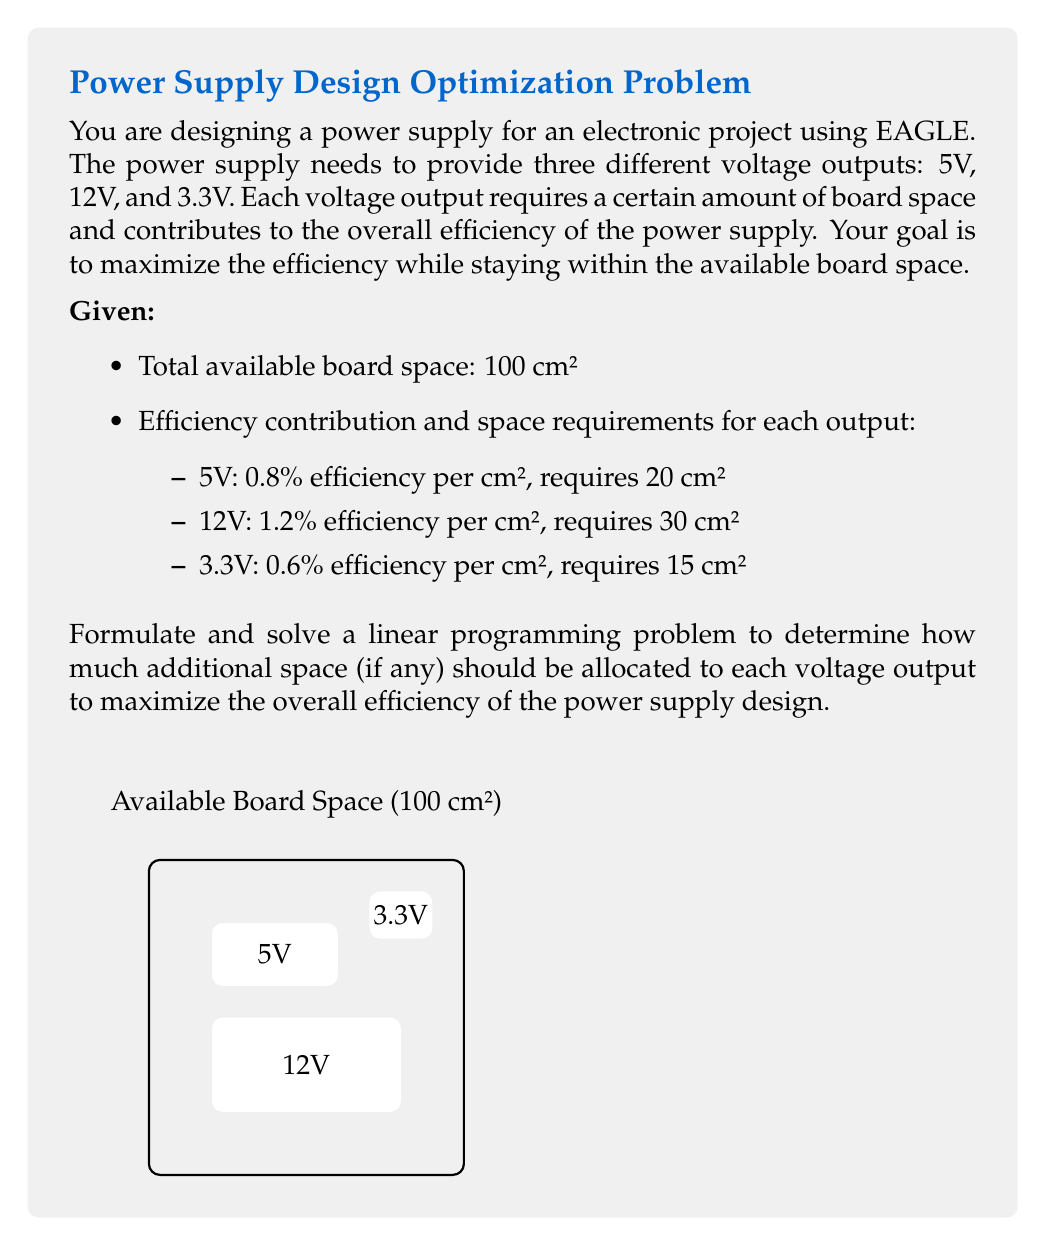Could you help me with this problem? Let's solve this linear programming problem step by step:

1) Define variables:
   Let $x_1$, $x_2$, and $x_3$ be the additional space allocated to 5V, 12V, and 3.3V outputs respectively.

2) Objective function:
   Maximize efficiency = $0.8x_1 + 1.2x_2 + 0.6x_3$

3) Constraints:
   a) Space constraint: $(20 + x_1) + (30 + x_2) + (15 + x_3) \leq 100$
      Simplifying: $x_1 + x_2 + x_3 \leq 35$
   b) Non-negativity: $x_1 \geq 0$, $x_2 \geq 0$, $x_3 \geq 0$

4) Standard form:
   Maximize: $Z = 0.8x_1 + 1.2x_2 + 0.6x_3$
   Subject to:
   $x_1 + x_2 + x_3 \leq 35$
   $x_1, x_2, x_3 \geq 0$

5) Solve using the simplex method or graphical method:
   The optimal solution is at the corner point where the constraint line intersects the axis of the variable with the highest coefficient in the objective function.

6) The optimal solution is:
   $x_1 = 0$, $x_2 = 35$, $x_3 = 0$

7) Interpretation:
   Allocate all additional space (35 cm²) to the 12V output for maximum efficiency.

8) Final allocation:
   5V: 20 cm² (no change)
   12V: 65 cm² (30 + 35)
   3.3V: 15 cm² (no change)

9) Maximum efficiency gain:
   $1.2 \times 35 = 42\%$
Answer: Allocate 35 cm² additional space to 12V output; efficiency gain: 42% 